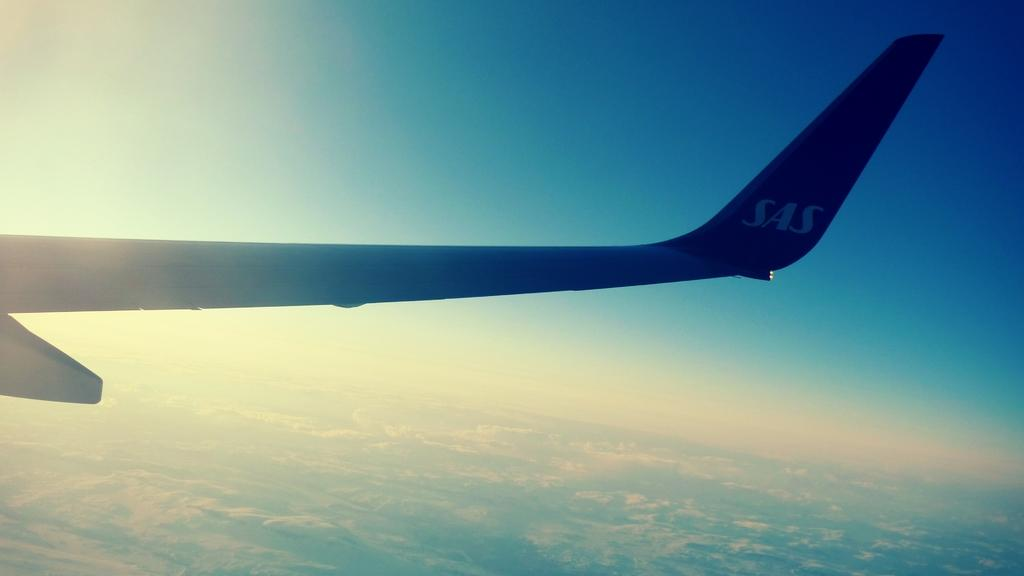Provide a one-sentence caption for the provided image. an SAS airplane wing tip from the airplane window. 